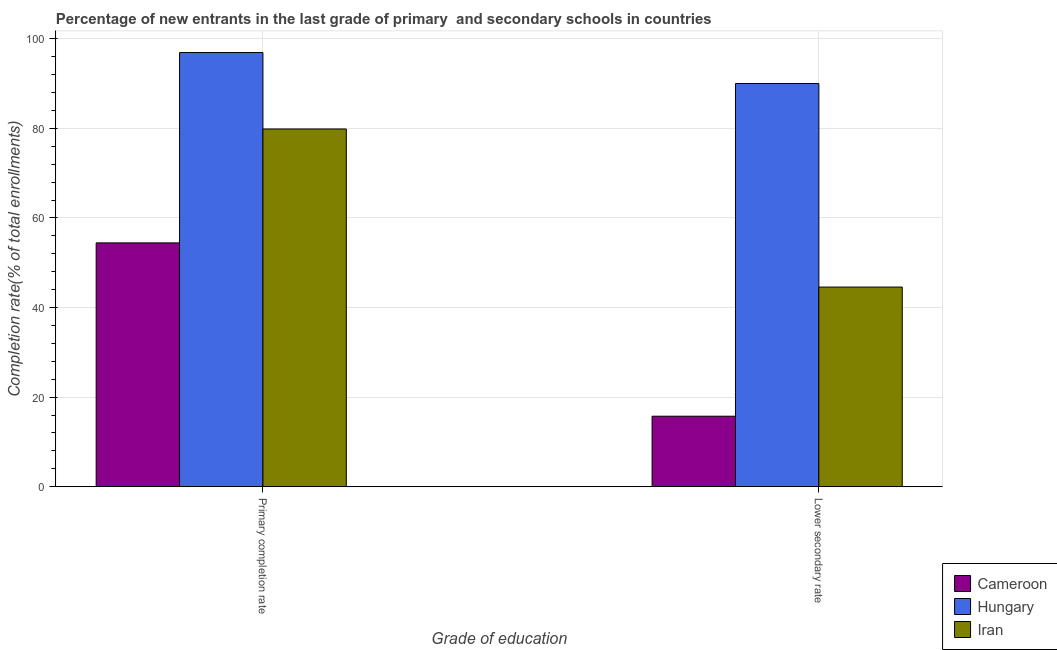How many different coloured bars are there?
Provide a succinct answer. 3. Are the number of bars per tick equal to the number of legend labels?
Your answer should be very brief. Yes. Are the number of bars on each tick of the X-axis equal?
Give a very brief answer. Yes. How many bars are there on the 1st tick from the right?
Your response must be concise. 3. What is the label of the 2nd group of bars from the left?
Make the answer very short. Lower secondary rate. What is the completion rate in secondary schools in Hungary?
Your answer should be compact. 90.01. Across all countries, what is the maximum completion rate in secondary schools?
Ensure brevity in your answer.  90.01. Across all countries, what is the minimum completion rate in secondary schools?
Offer a very short reply. 15.74. In which country was the completion rate in primary schools maximum?
Provide a succinct answer. Hungary. In which country was the completion rate in secondary schools minimum?
Provide a succinct answer. Cameroon. What is the total completion rate in primary schools in the graph?
Give a very brief answer. 231.23. What is the difference between the completion rate in primary schools in Cameroon and that in Hungary?
Make the answer very short. -42.49. What is the difference between the completion rate in primary schools in Iran and the completion rate in secondary schools in Cameroon?
Your answer should be compact. 64.12. What is the average completion rate in primary schools per country?
Ensure brevity in your answer.  77.08. What is the difference between the completion rate in primary schools and completion rate in secondary schools in Cameroon?
Ensure brevity in your answer.  38.69. In how many countries, is the completion rate in primary schools greater than 68 %?
Provide a short and direct response. 2. What is the ratio of the completion rate in secondary schools in Cameroon to that in Hungary?
Your answer should be very brief. 0.17. Is the completion rate in primary schools in Cameroon less than that in Iran?
Give a very brief answer. Yes. What does the 3rd bar from the left in Lower secondary rate represents?
Give a very brief answer. Iran. What does the 2nd bar from the right in Primary completion rate represents?
Ensure brevity in your answer.  Hungary. How many bars are there?
Make the answer very short. 6. Are the values on the major ticks of Y-axis written in scientific E-notation?
Offer a terse response. No. Where does the legend appear in the graph?
Ensure brevity in your answer.  Bottom right. How many legend labels are there?
Your answer should be very brief. 3. What is the title of the graph?
Give a very brief answer. Percentage of new entrants in the last grade of primary  and secondary schools in countries. What is the label or title of the X-axis?
Provide a short and direct response. Grade of education. What is the label or title of the Y-axis?
Your answer should be compact. Completion rate(% of total enrollments). What is the Completion rate(% of total enrollments) of Cameroon in Primary completion rate?
Offer a terse response. 54.44. What is the Completion rate(% of total enrollments) in Hungary in Primary completion rate?
Your answer should be very brief. 96.93. What is the Completion rate(% of total enrollments) of Iran in Primary completion rate?
Your response must be concise. 79.86. What is the Completion rate(% of total enrollments) in Cameroon in Lower secondary rate?
Give a very brief answer. 15.74. What is the Completion rate(% of total enrollments) of Hungary in Lower secondary rate?
Your answer should be compact. 90.01. What is the Completion rate(% of total enrollments) of Iran in Lower secondary rate?
Offer a terse response. 44.57. Across all Grade of education, what is the maximum Completion rate(% of total enrollments) in Cameroon?
Ensure brevity in your answer.  54.44. Across all Grade of education, what is the maximum Completion rate(% of total enrollments) of Hungary?
Ensure brevity in your answer.  96.93. Across all Grade of education, what is the maximum Completion rate(% of total enrollments) of Iran?
Your response must be concise. 79.86. Across all Grade of education, what is the minimum Completion rate(% of total enrollments) in Cameroon?
Provide a short and direct response. 15.74. Across all Grade of education, what is the minimum Completion rate(% of total enrollments) in Hungary?
Provide a succinct answer. 90.01. Across all Grade of education, what is the minimum Completion rate(% of total enrollments) of Iran?
Keep it short and to the point. 44.57. What is the total Completion rate(% of total enrollments) in Cameroon in the graph?
Give a very brief answer. 70.18. What is the total Completion rate(% of total enrollments) in Hungary in the graph?
Your response must be concise. 186.94. What is the total Completion rate(% of total enrollments) of Iran in the graph?
Make the answer very short. 124.43. What is the difference between the Completion rate(% of total enrollments) in Cameroon in Primary completion rate and that in Lower secondary rate?
Your response must be concise. 38.69. What is the difference between the Completion rate(% of total enrollments) in Hungary in Primary completion rate and that in Lower secondary rate?
Keep it short and to the point. 6.92. What is the difference between the Completion rate(% of total enrollments) of Iran in Primary completion rate and that in Lower secondary rate?
Your response must be concise. 35.29. What is the difference between the Completion rate(% of total enrollments) of Cameroon in Primary completion rate and the Completion rate(% of total enrollments) of Hungary in Lower secondary rate?
Offer a very short reply. -35.58. What is the difference between the Completion rate(% of total enrollments) of Cameroon in Primary completion rate and the Completion rate(% of total enrollments) of Iran in Lower secondary rate?
Make the answer very short. 9.86. What is the difference between the Completion rate(% of total enrollments) in Hungary in Primary completion rate and the Completion rate(% of total enrollments) in Iran in Lower secondary rate?
Provide a short and direct response. 52.36. What is the average Completion rate(% of total enrollments) of Cameroon per Grade of education?
Ensure brevity in your answer.  35.09. What is the average Completion rate(% of total enrollments) in Hungary per Grade of education?
Give a very brief answer. 93.47. What is the average Completion rate(% of total enrollments) of Iran per Grade of education?
Provide a succinct answer. 62.22. What is the difference between the Completion rate(% of total enrollments) in Cameroon and Completion rate(% of total enrollments) in Hungary in Primary completion rate?
Give a very brief answer. -42.49. What is the difference between the Completion rate(% of total enrollments) of Cameroon and Completion rate(% of total enrollments) of Iran in Primary completion rate?
Offer a very short reply. -25.43. What is the difference between the Completion rate(% of total enrollments) of Hungary and Completion rate(% of total enrollments) of Iran in Primary completion rate?
Provide a short and direct response. 17.07. What is the difference between the Completion rate(% of total enrollments) of Cameroon and Completion rate(% of total enrollments) of Hungary in Lower secondary rate?
Provide a succinct answer. -74.27. What is the difference between the Completion rate(% of total enrollments) of Cameroon and Completion rate(% of total enrollments) of Iran in Lower secondary rate?
Your response must be concise. -28.83. What is the difference between the Completion rate(% of total enrollments) in Hungary and Completion rate(% of total enrollments) in Iran in Lower secondary rate?
Your answer should be compact. 45.44. What is the ratio of the Completion rate(% of total enrollments) of Cameroon in Primary completion rate to that in Lower secondary rate?
Offer a very short reply. 3.46. What is the ratio of the Completion rate(% of total enrollments) of Iran in Primary completion rate to that in Lower secondary rate?
Provide a succinct answer. 1.79. What is the difference between the highest and the second highest Completion rate(% of total enrollments) of Cameroon?
Offer a terse response. 38.69. What is the difference between the highest and the second highest Completion rate(% of total enrollments) of Hungary?
Your answer should be very brief. 6.92. What is the difference between the highest and the second highest Completion rate(% of total enrollments) in Iran?
Your answer should be very brief. 35.29. What is the difference between the highest and the lowest Completion rate(% of total enrollments) of Cameroon?
Provide a succinct answer. 38.69. What is the difference between the highest and the lowest Completion rate(% of total enrollments) of Hungary?
Ensure brevity in your answer.  6.92. What is the difference between the highest and the lowest Completion rate(% of total enrollments) of Iran?
Give a very brief answer. 35.29. 